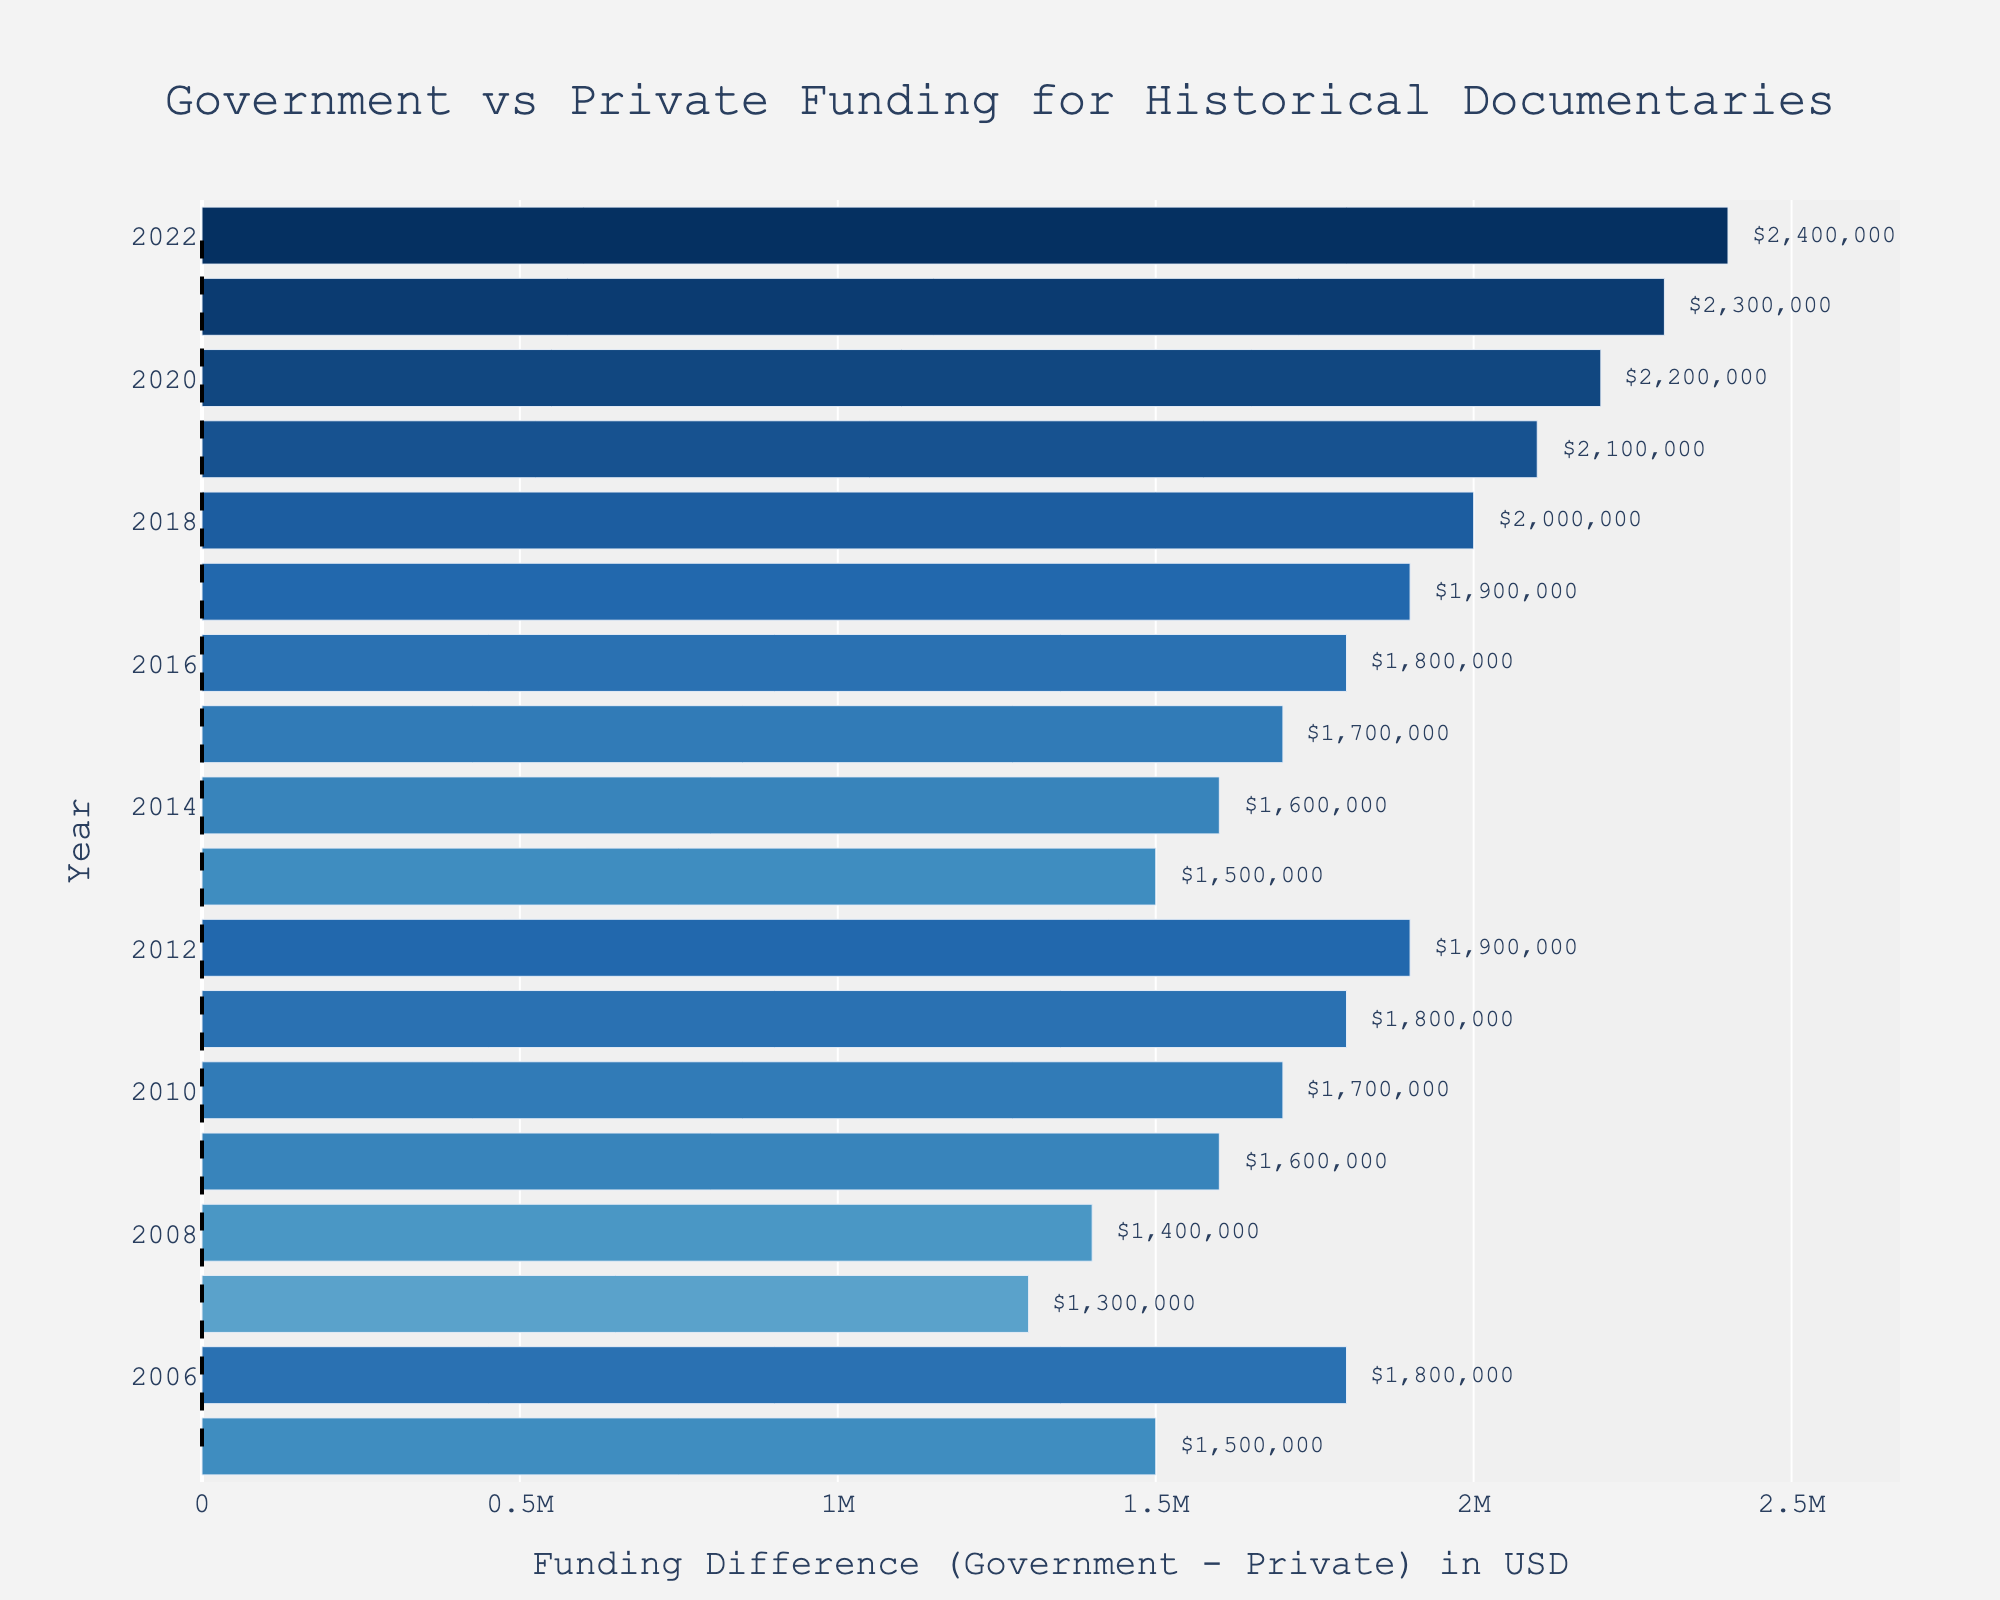Which year had the highest funding difference? The chart visually shows the funding differences for each year. The longest bar towards the right represents the highest funding difference, which corresponds to the year 2022.
Answer: 2022 Which year had the smallest funding difference? This is represented by the smallest bar on the chart. The smallest positive bar or bar closest to zero corresponds to the year 2006.
Answer: 2006 Between 2010 and 2015, during which year did the government have the greatest surplus over private funding? Check the bars for the years 2010 to 2015, and identify which year had the longest bar towards the right. The year with the longest bar in this range is 2015.
Answer: 2015 In how many years did the government funding exceed private funding by more than $2,000,000? Identify the number of bars extending more than $2,000,000 to the right. These are the bars for the years 2017 through 2022. Count these bars to find the number of years.
Answer: 6 years Was there any year in which private funding exceeded government funding? Check if any bars extend to the left side of the chart (negative values). Since all bars are extending to the right, indicating that all differences are positive, there are no years where private funding exceeded government funding.
Answer: No What is the range of government funding difference from 2005 to 2022? Identify the longest bar on the right (2022) and the shortest on the right (2006). The range is the difference between these two values, $2400000 (5500000 - 3100000).
Answer: $2400000 Which year saw the biggest increase in funding difference compared to the previous year? Compare the length of bars year by year. The year that shows the biggest jump from its preceding year's bar is between 2021 and 2022, with an increase of $200,000 ($2,400,000 - $2,200,000).
Answer: 2022 During which year was the funding difference exactly $3,000,000? Identify the bar marked with the annotation text '$3,000,000'. This corresponds to the year 2020.
Answer: 2020 